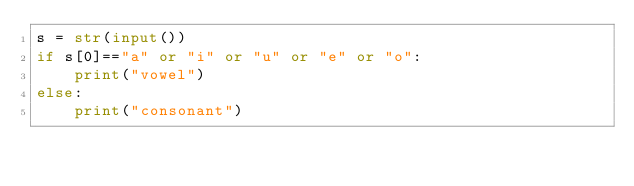<code> <loc_0><loc_0><loc_500><loc_500><_Python_>s = str(input())
if s[0]=="a" or "i" or "u" or "e" or "o":
    print("vowel")
else:
    print("consonant")</code> 